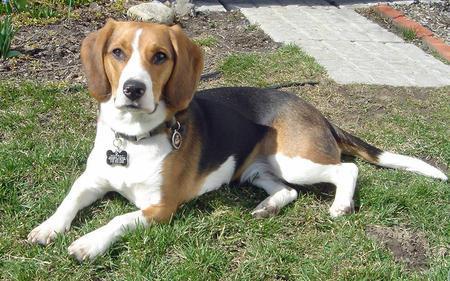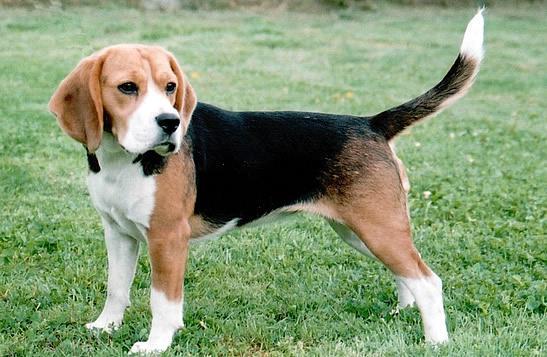The first image is the image on the left, the second image is the image on the right. Assess this claim about the two images: "The dog in the image on the left is wearing a leash.". Correct or not? Answer yes or no. No. 